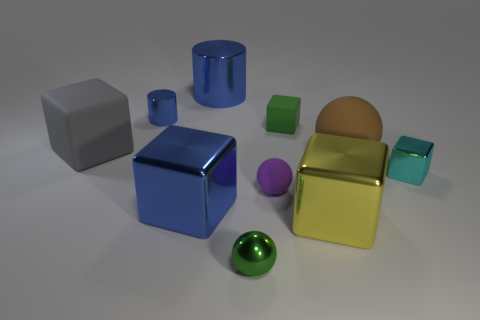Subtract all matte spheres. How many spheres are left? 1 Subtract all gray cubes. How many cubes are left? 4 Subtract all cylinders. How many objects are left? 8 Subtract all green blocks. Subtract all red balls. How many blocks are left? 4 Subtract all brown cylinders. How many green cubes are left? 1 Subtract all small green objects. Subtract all brown blocks. How many objects are left? 8 Add 4 large blue cubes. How many large blue cubes are left? 5 Add 6 green matte cubes. How many green matte cubes exist? 7 Subtract 0 brown cylinders. How many objects are left? 10 Subtract 1 blocks. How many blocks are left? 4 